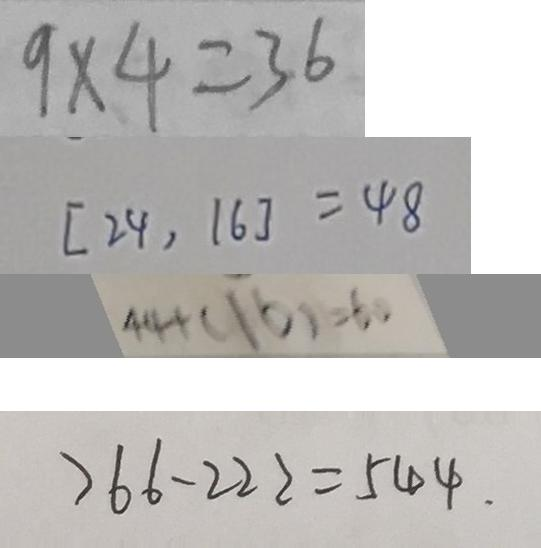<formula> <loc_0><loc_0><loc_500><loc_500>9 \times 4 = 3 6 
 [ 2 4 , 1 6 ] = 4 8 
 4 4 + ( 1 6 ) = 6 0 
 7 6 6 - 2 2 2 = 5 4 4 .</formula> 